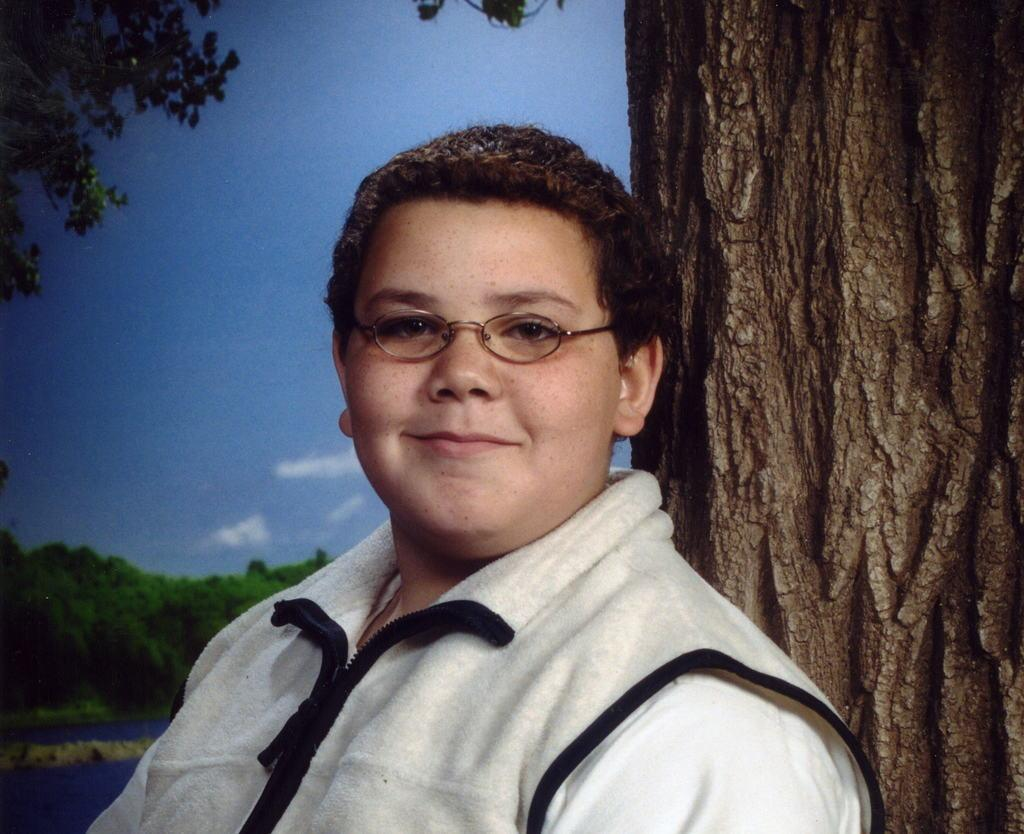What is the main subject of the image? There is a boy standing in the center of the image. What is the boy wearing? The boy is wearing a jacket. What can be seen in the background of the image? There are trees and the sky visible in the background of the image. What type of destruction can be seen in the image? There is no destruction present in the image; it features a boy standing in the center of the image with trees and the sky in the background. Is the boy using a quill to write in the image? There is no quill or writing activity depicted in the image. 